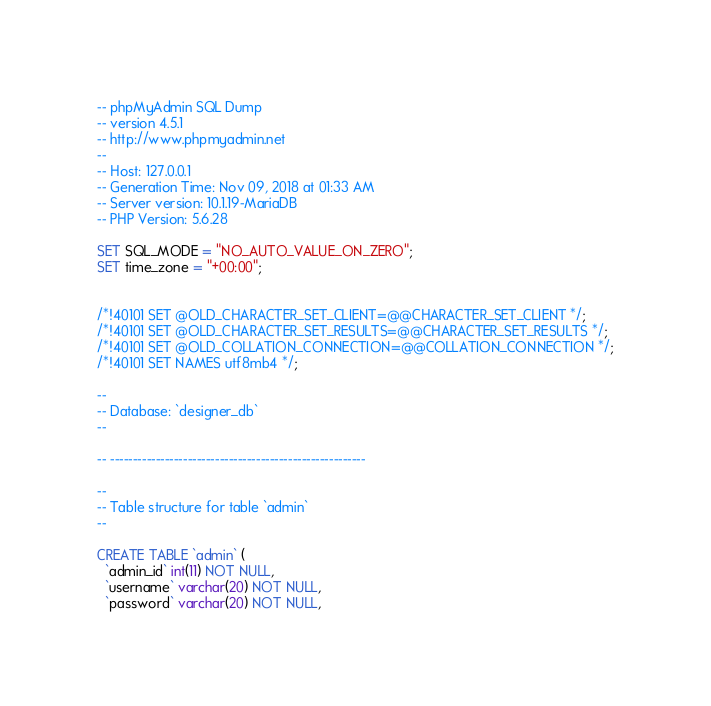Convert code to text. <code><loc_0><loc_0><loc_500><loc_500><_SQL_>-- phpMyAdmin SQL Dump
-- version 4.5.1
-- http://www.phpmyadmin.net
--
-- Host: 127.0.0.1
-- Generation Time: Nov 09, 2018 at 01:33 AM
-- Server version: 10.1.19-MariaDB
-- PHP Version: 5.6.28

SET SQL_MODE = "NO_AUTO_VALUE_ON_ZERO";
SET time_zone = "+00:00";


/*!40101 SET @OLD_CHARACTER_SET_CLIENT=@@CHARACTER_SET_CLIENT */;
/*!40101 SET @OLD_CHARACTER_SET_RESULTS=@@CHARACTER_SET_RESULTS */;
/*!40101 SET @OLD_COLLATION_CONNECTION=@@COLLATION_CONNECTION */;
/*!40101 SET NAMES utf8mb4 */;

--
-- Database: `designer_db`
--

-- --------------------------------------------------------

--
-- Table structure for table `admin`
--

CREATE TABLE `admin` (
  `admin_id` int(11) NOT NULL,
  `username` varchar(20) NOT NULL,
  `password` varchar(20) NOT NULL,</code> 